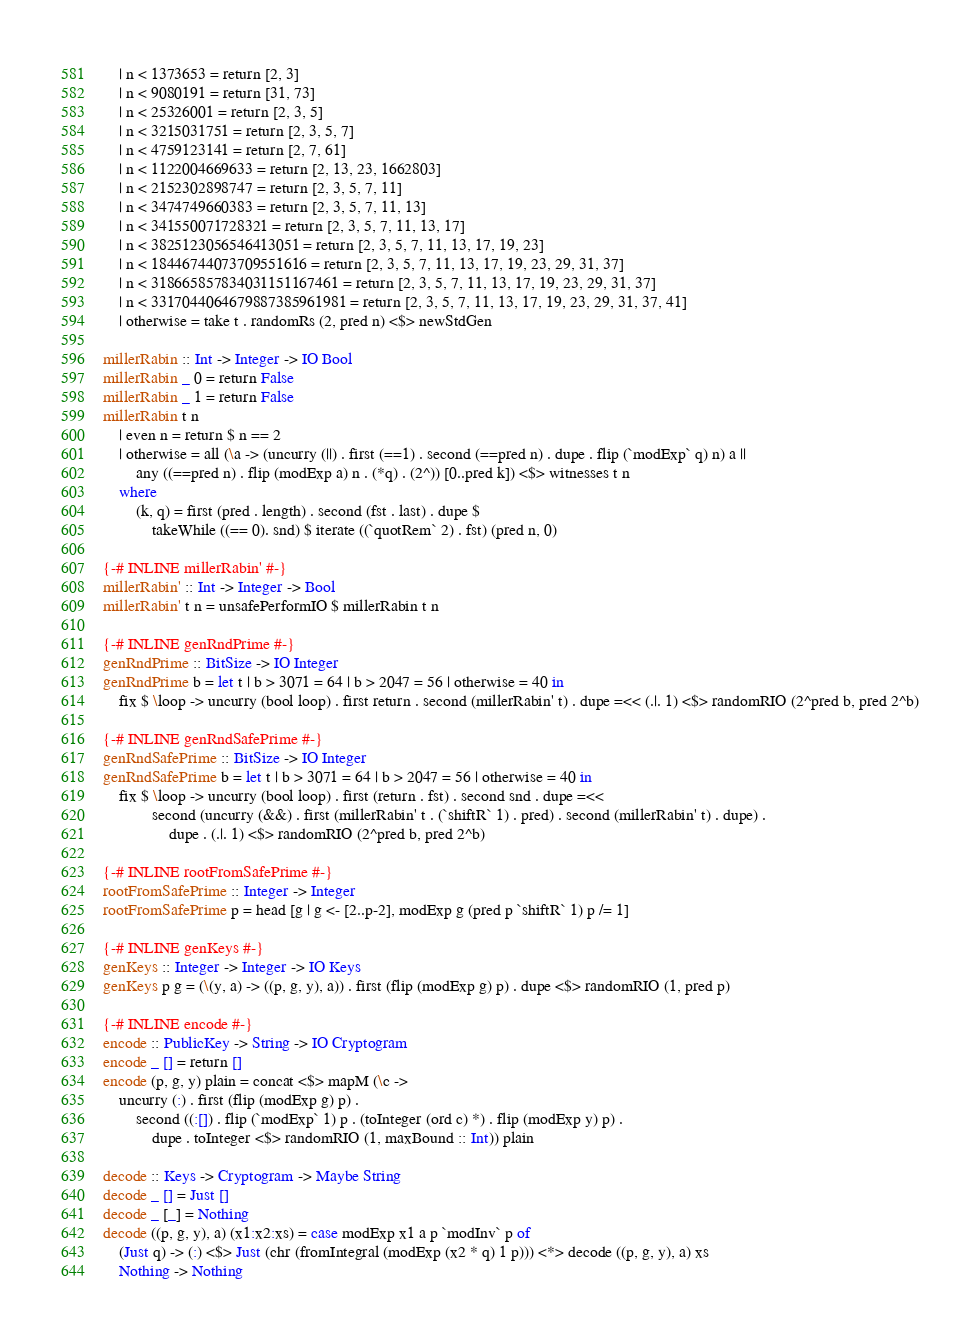<code> <loc_0><loc_0><loc_500><loc_500><_Haskell_>    | n < 1373653 = return [2, 3]
    | n < 9080191 = return [31, 73]
    | n < 25326001 = return [2, 3, 5]
    | n < 3215031751 = return [2, 3, 5, 7]
    | n < 4759123141 = return [2, 7, 61]
    | n < 1122004669633 = return [2, 13, 23, 1662803]
    | n < 2152302898747 = return [2, 3, 5, 7, 11]
    | n < 3474749660383 = return [2, 3, 5, 7, 11, 13]
    | n < 341550071728321 = return [2, 3, 5, 7, 11, 13, 17]
    | n < 3825123056546413051 = return [2, 3, 5, 7, 11, 13, 17, 19, 23]
    | n < 18446744073709551616 = return [2, 3, 5, 7, 11, 13, 17, 19, 23, 29, 31, 37]
    | n < 318665857834031151167461 = return [2, 3, 5, 7, 11, 13, 17, 19, 23, 29, 31, 37]
    | n < 3317044064679887385961981 = return [2, 3, 5, 7, 11, 13, 17, 19, 23, 29, 31, 37, 41]
    | otherwise = take t . randomRs (2, pred n) <$> newStdGen

millerRabin :: Int -> Integer -> IO Bool
millerRabin _ 0 = return False
millerRabin _ 1 = return False
millerRabin t n
    | even n = return $ n == 2
    | otherwise = all (\a -> (uncurry (||) . first (==1) . second (==pred n) . dupe . flip (`modExp` q) n) a || 
        any ((==pred n) . flip (modExp a) n . (*q) . (2^)) [0..pred k]) <$> witnesses t n
    where 
        (k, q) = first (pred . length) . second (fst . last) . dupe $ 
            takeWhile ((== 0). snd) $ iterate ((`quotRem` 2) . fst) (pred n, 0) 

{-# INLINE millerRabin' #-}
millerRabin' :: Int -> Integer -> Bool
millerRabin' t n = unsafePerformIO $ millerRabin t n

{-# INLINE genRndPrime #-}
genRndPrime :: BitSize -> IO Integer
genRndPrime b = let t | b > 3071 = 64 | b > 2047 = 56 | otherwise = 40 in
    fix $ \loop -> uncurry (bool loop) . first return . second (millerRabin' t) . dupe =<< (.|. 1) <$> randomRIO (2^pred b, pred 2^b)

{-# INLINE genRndSafePrime #-}
genRndSafePrime :: BitSize -> IO Integer
genRndSafePrime b = let t | b > 3071 = 64 | b > 2047 = 56 | otherwise = 40 in
    fix $ \loop -> uncurry (bool loop) . first (return . fst) . second snd . dupe =<< 
            second (uncurry (&&) . first (millerRabin' t . (`shiftR` 1) . pred) . second (millerRabin' t) . dupe) .
                dupe . (.|. 1) <$> randomRIO (2^pred b, pred 2^b)

{-# INLINE rootFromSafePrime #-}
rootFromSafePrime :: Integer -> Integer
rootFromSafePrime p = head [g | g <- [2..p-2], modExp g (pred p `shiftR` 1) p /= 1]

{-# INLINE genKeys #-}
genKeys :: Integer -> Integer -> IO Keys
genKeys p g = (\(y, a) -> ((p, g, y), a)) . first (flip (modExp g) p) . dupe <$> randomRIO (1, pred p)
 
{-# INLINE encode #-}
encode :: PublicKey -> String -> IO Cryptogram
encode _ [] = return []
encode (p, g, y) plain = concat <$> mapM (\c -> 
    uncurry (:) . first (flip (modExp g) p) . 
        second ((:[]) . flip (`modExp` 1) p . (toInteger (ord c) *) . flip (modExp y) p) . 
            dupe . toInteger <$> randomRIO (1, maxBound :: Int)) plain

decode :: Keys -> Cryptogram -> Maybe String
decode _ [] = Just []
decode _ [_] = Nothing
decode ((p, g, y), a) (x1:x2:xs) = case modExp x1 a p `modInv` p of
    (Just q) -> (:) <$> Just (chr (fromIntegral (modExp (x2 * q) 1 p))) <*> decode ((p, g, y), a) xs
    Nothing -> Nothing
</code> 